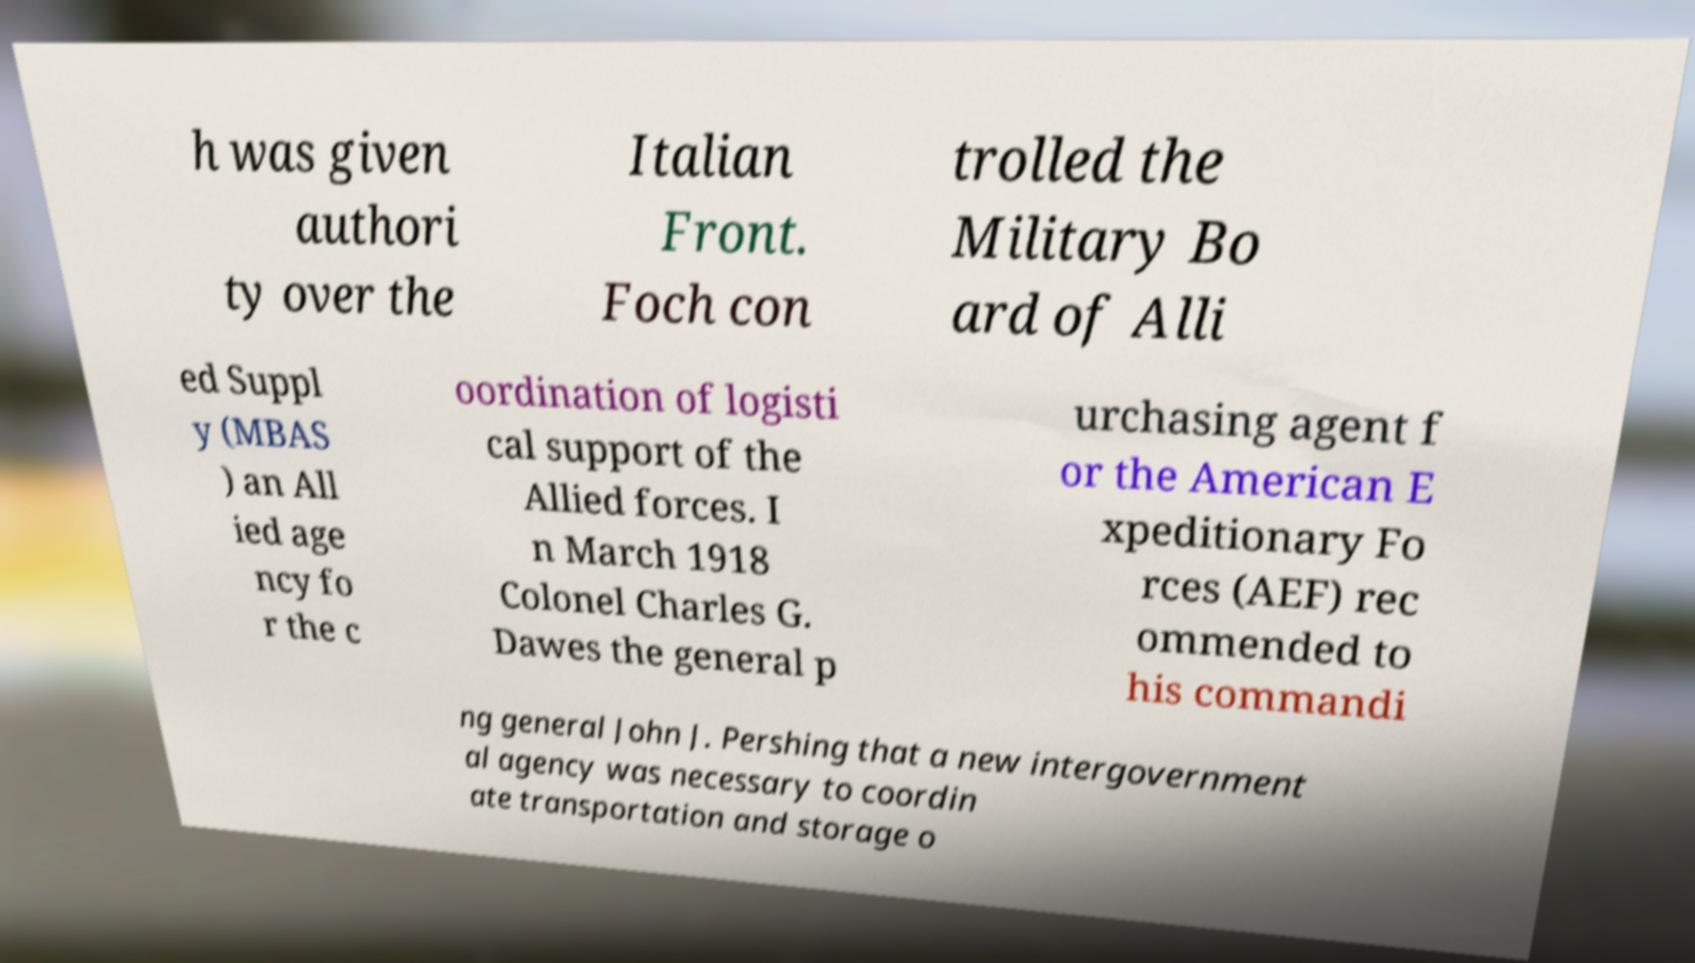For documentation purposes, I need the text within this image transcribed. Could you provide that? h was given authori ty over the Italian Front. Foch con trolled the Military Bo ard of Alli ed Suppl y (MBAS ) an All ied age ncy fo r the c oordination of logisti cal support of the Allied forces. I n March 1918 Colonel Charles G. Dawes the general p urchasing agent f or the American E xpeditionary Fo rces (AEF) rec ommended to his commandi ng general John J. Pershing that a new intergovernment al agency was necessary to coordin ate transportation and storage o 